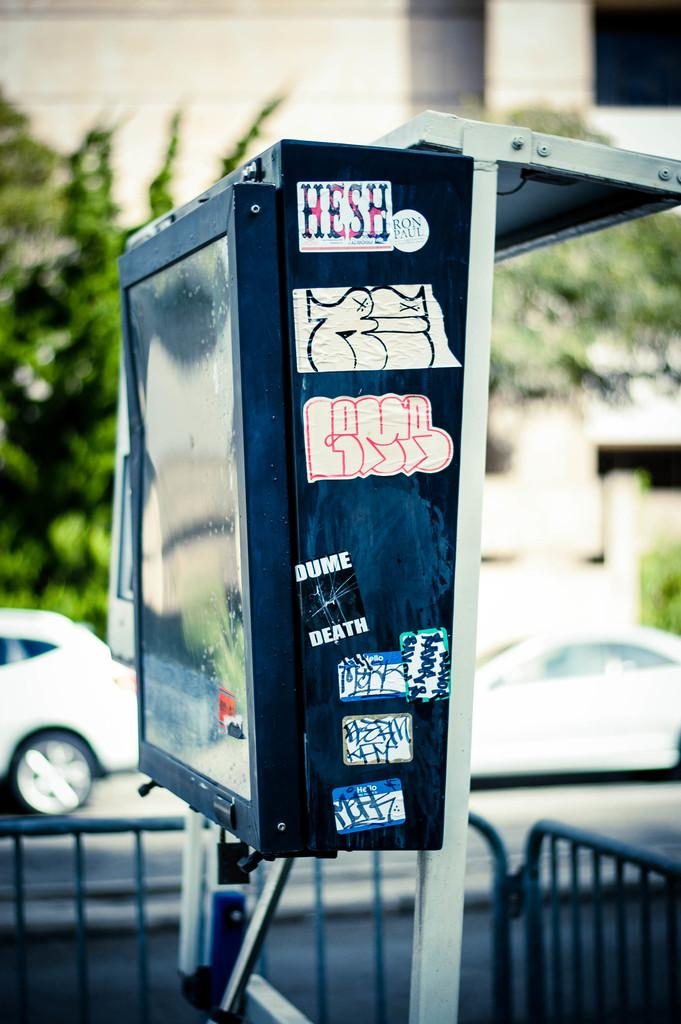What object can be seen in the image that is typically used for storage or transportation? There is a box in the image. What structure is visible in the image that is used to separate or enclose an area? There is a fence in the image. What vehicles can be seen on the road in the image? There are cars on the road in the image. What type of natural scenery is visible in the background of the image? There are trees in the background of the image. What type of man-made structure is visible in the background of the image? There is a building in the background of the image. What type of wool is being used to make the fence in the image? There is no wool present in the image, as the fence is made of a different material. What month is it in the image? The month cannot be determined from the image, as there is no indication of the time of year. 